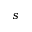<formula> <loc_0><loc_0><loc_500><loc_500>s</formula> 